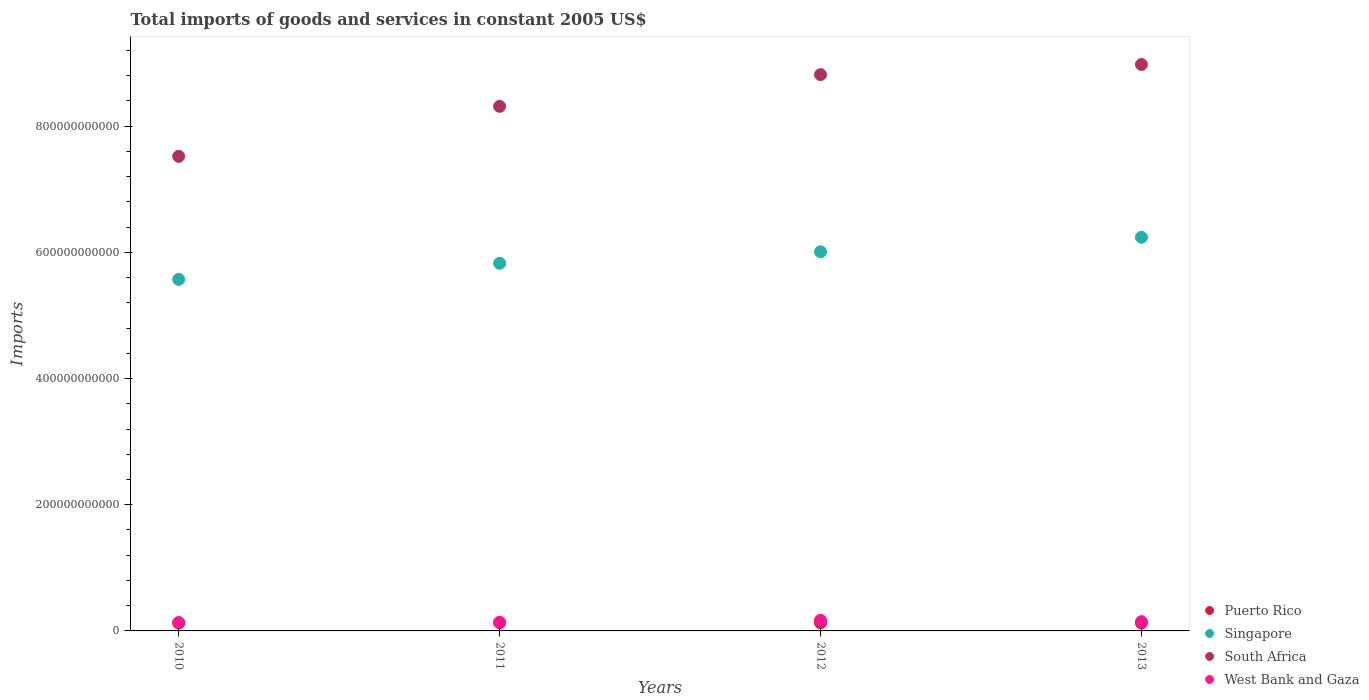Is the number of dotlines equal to the number of legend labels?
Give a very brief answer. Yes. What is the total imports of goods and services in Singapore in 2012?
Make the answer very short. 6.01e+11. Across all years, what is the maximum total imports of goods and services in South Africa?
Provide a succinct answer. 8.98e+11. Across all years, what is the minimum total imports of goods and services in West Bank and Gaza?
Your response must be concise. 1.33e+1. In which year was the total imports of goods and services in West Bank and Gaza minimum?
Provide a succinct answer. 2010. What is the total total imports of goods and services in West Bank and Gaza in the graph?
Your answer should be compact. 5.85e+1. What is the difference between the total imports of goods and services in West Bank and Gaza in 2012 and that in 2013?
Give a very brief answer. 2.19e+09. What is the difference between the total imports of goods and services in West Bank and Gaza in 2013 and the total imports of goods and services in Singapore in 2012?
Make the answer very short. -5.86e+11. What is the average total imports of goods and services in South Africa per year?
Keep it short and to the point. 8.41e+11. In the year 2013, what is the difference between the total imports of goods and services in West Bank and Gaza and total imports of goods and services in Singapore?
Provide a short and direct response. -6.09e+11. What is the ratio of the total imports of goods and services in South Africa in 2011 to that in 2012?
Make the answer very short. 0.94. Is the difference between the total imports of goods and services in West Bank and Gaza in 2010 and 2011 greater than the difference between the total imports of goods and services in Singapore in 2010 and 2011?
Your answer should be very brief. Yes. What is the difference between the highest and the second highest total imports of goods and services in Puerto Rico?
Give a very brief answer. 2.42e+07. What is the difference between the highest and the lowest total imports of goods and services in Puerto Rico?
Provide a succinct answer. 4.58e+08. Is the sum of the total imports of goods and services in South Africa in 2010 and 2011 greater than the maximum total imports of goods and services in Singapore across all years?
Give a very brief answer. Yes. Is it the case that in every year, the sum of the total imports of goods and services in Singapore and total imports of goods and services in West Bank and Gaza  is greater than the sum of total imports of goods and services in South Africa and total imports of goods and services in Puerto Rico?
Offer a very short reply. No. Is the total imports of goods and services in Puerto Rico strictly greater than the total imports of goods and services in South Africa over the years?
Make the answer very short. No. Is the total imports of goods and services in West Bank and Gaza strictly less than the total imports of goods and services in Singapore over the years?
Give a very brief answer. Yes. What is the difference between two consecutive major ticks on the Y-axis?
Your response must be concise. 2.00e+11. Does the graph contain grids?
Give a very brief answer. No. How are the legend labels stacked?
Keep it short and to the point. Vertical. What is the title of the graph?
Keep it short and to the point. Total imports of goods and services in constant 2005 US$. What is the label or title of the X-axis?
Your response must be concise. Years. What is the label or title of the Y-axis?
Give a very brief answer. Imports. What is the Imports of Puerto Rico in 2010?
Keep it short and to the point. 1.25e+1. What is the Imports in Singapore in 2010?
Provide a short and direct response. 5.57e+11. What is the Imports of South Africa in 2010?
Offer a very short reply. 7.52e+11. What is the Imports in West Bank and Gaza in 2010?
Ensure brevity in your answer.  1.33e+1. What is the Imports of Puerto Rico in 2011?
Offer a terse response. 1.29e+1. What is the Imports of Singapore in 2011?
Make the answer very short. 5.83e+11. What is the Imports in South Africa in 2011?
Your answer should be very brief. 8.31e+11. What is the Imports of West Bank and Gaza in 2011?
Offer a terse response. 1.37e+1. What is the Imports in Puerto Rico in 2012?
Ensure brevity in your answer.  1.29e+1. What is the Imports of Singapore in 2012?
Offer a very short reply. 6.01e+11. What is the Imports of South Africa in 2012?
Keep it short and to the point. 8.82e+11. What is the Imports of West Bank and Gaza in 2012?
Your response must be concise. 1.68e+1. What is the Imports in Puerto Rico in 2013?
Provide a short and direct response. 1.27e+1. What is the Imports in Singapore in 2013?
Make the answer very short. 6.24e+11. What is the Imports in South Africa in 2013?
Your response must be concise. 8.98e+11. What is the Imports in West Bank and Gaza in 2013?
Offer a terse response. 1.47e+1. Across all years, what is the maximum Imports of Puerto Rico?
Your response must be concise. 1.29e+1. Across all years, what is the maximum Imports of Singapore?
Make the answer very short. 6.24e+11. Across all years, what is the maximum Imports of South Africa?
Provide a succinct answer. 8.98e+11. Across all years, what is the maximum Imports of West Bank and Gaza?
Give a very brief answer. 1.68e+1. Across all years, what is the minimum Imports in Puerto Rico?
Provide a short and direct response. 1.25e+1. Across all years, what is the minimum Imports of Singapore?
Provide a succinct answer. 5.57e+11. Across all years, what is the minimum Imports of South Africa?
Your answer should be very brief. 7.52e+11. Across all years, what is the minimum Imports of West Bank and Gaza?
Your answer should be compact. 1.33e+1. What is the total Imports of Puerto Rico in the graph?
Provide a short and direct response. 5.11e+1. What is the total Imports in Singapore in the graph?
Offer a very short reply. 2.36e+12. What is the total Imports in South Africa in the graph?
Your answer should be very brief. 3.36e+12. What is the total Imports in West Bank and Gaza in the graph?
Your answer should be compact. 5.85e+1. What is the difference between the Imports of Puerto Rico in 2010 and that in 2011?
Offer a terse response. -4.34e+08. What is the difference between the Imports of Singapore in 2010 and that in 2011?
Provide a succinct answer. -2.56e+1. What is the difference between the Imports in South Africa in 2010 and that in 2011?
Keep it short and to the point. -7.92e+1. What is the difference between the Imports in West Bank and Gaza in 2010 and that in 2011?
Your answer should be very brief. -4.48e+08. What is the difference between the Imports in Puerto Rico in 2010 and that in 2012?
Give a very brief answer. -4.58e+08. What is the difference between the Imports of Singapore in 2010 and that in 2012?
Give a very brief answer. -4.38e+1. What is the difference between the Imports in South Africa in 2010 and that in 2012?
Give a very brief answer. -1.30e+11. What is the difference between the Imports of West Bank and Gaza in 2010 and that in 2012?
Keep it short and to the point. -3.59e+09. What is the difference between the Imports in Puerto Rico in 2010 and that in 2013?
Make the answer very short. -2.29e+08. What is the difference between the Imports in Singapore in 2010 and that in 2013?
Ensure brevity in your answer.  -6.68e+1. What is the difference between the Imports of South Africa in 2010 and that in 2013?
Ensure brevity in your answer.  -1.46e+11. What is the difference between the Imports of West Bank and Gaza in 2010 and that in 2013?
Your answer should be very brief. -1.40e+09. What is the difference between the Imports in Puerto Rico in 2011 and that in 2012?
Your answer should be very brief. -2.42e+07. What is the difference between the Imports in Singapore in 2011 and that in 2012?
Provide a short and direct response. -1.82e+1. What is the difference between the Imports of South Africa in 2011 and that in 2012?
Provide a short and direct response. -5.03e+1. What is the difference between the Imports in West Bank and Gaza in 2011 and that in 2012?
Provide a succinct answer. -3.14e+09. What is the difference between the Imports of Puerto Rico in 2011 and that in 2013?
Provide a succinct answer. 2.05e+08. What is the difference between the Imports of Singapore in 2011 and that in 2013?
Offer a very short reply. -4.12e+1. What is the difference between the Imports in South Africa in 2011 and that in 2013?
Provide a short and direct response. -6.63e+1. What is the difference between the Imports in West Bank and Gaza in 2011 and that in 2013?
Your answer should be compact. -9.47e+08. What is the difference between the Imports in Puerto Rico in 2012 and that in 2013?
Ensure brevity in your answer.  2.29e+08. What is the difference between the Imports in Singapore in 2012 and that in 2013?
Your answer should be very brief. -2.30e+1. What is the difference between the Imports of South Africa in 2012 and that in 2013?
Offer a terse response. -1.60e+1. What is the difference between the Imports in West Bank and Gaza in 2012 and that in 2013?
Give a very brief answer. 2.19e+09. What is the difference between the Imports in Puerto Rico in 2010 and the Imports in Singapore in 2011?
Offer a very short reply. -5.70e+11. What is the difference between the Imports in Puerto Rico in 2010 and the Imports in South Africa in 2011?
Ensure brevity in your answer.  -8.19e+11. What is the difference between the Imports in Puerto Rico in 2010 and the Imports in West Bank and Gaza in 2011?
Your answer should be very brief. -1.22e+09. What is the difference between the Imports of Singapore in 2010 and the Imports of South Africa in 2011?
Offer a very short reply. -2.74e+11. What is the difference between the Imports of Singapore in 2010 and the Imports of West Bank and Gaza in 2011?
Your response must be concise. 5.43e+11. What is the difference between the Imports in South Africa in 2010 and the Imports in West Bank and Gaza in 2011?
Ensure brevity in your answer.  7.39e+11. What is the difference between the Imports of Puerto Rico in 2010 and the Imports of Singapore in 2012?
Make the answer very short. -5.88e+11. What is the difference between the Imports in Puerto Rico in 2010 and the Imports in South Africa in 2012?
Give a very brief answer. -8.69e+11. What is the difference between the Imports in Puerto Rico in 2010 and the Imports in West Bank and Gaza in 2012?
Offer a very short reply. -4.36e+09. What is the difference between the Imports of Singapore in 2010 and the Imports of South Africa in 2012?
Ensure brevity in your answer.  -3.25e+11. What is the difference between the Imports of Singapore in 2010 and the Imports of West Bank and Gaza in 2012?
Give a very brief answer. 5.40e+11. What is the difference between the Imports in South Africa in 2010 and the Imports in West Bank and Gaza in 2012?
Your answer should be very brief. 7.35e+11. What is the difference between the Imports in Puerto Rico in 2010 and the Imports in Singapore in 2013?
Offer a very short reply. -6.11e+11. What is the difference between the Imports in Puerto Rico in 2010 and the Imports in South Africa in 2013?
Keep it short and to the point. -8.85e+11. What is the difference between the Imports of Puerto Rico in 2010 and the Imports of West Bank and Gaza in 2013?
Make the answer very short. -2.17e+09. What is the difference between the Imports in Singapore in 2010 and the Imports in South Africa in 2013?
Make the answer very short. -3.41e+11. What is the difference between the Imports in Singapore in 2010 and the Imports in West Bank and Gaza in 2013?
Offer a very short reply. 5.43e+11. What is the difference between the Imports in South Africa in 2010 and the Imports in West Bank and Gaza in 2013?
Provide a short and direct response. 7.38e+11. What is the difference between the Imports in Puerto Rico in 2011 and the Imports in Singapore in 2012?
Your answer should be compact. -5.88e+11. What is the difference between the Imports of Puerto Rico in 2011 and the Imports of South Africa in 2012?
Your answer should be very brief. -8.69e+11. What is the difference between the Imports in Puerto Rico in 2011 and the Imports in West Bank and Gaza in 2012?
Your answer should be compact. -3.93e+09. What is the difference between the Imports of Singapore in 2011 and the Imports of South Africa in 2012?
Your answer should be compact. -2.99e+11. What is the difference between the Imports of Singapore in 2011 and the Imports of West Bank and Gaza in 2012?
Give a very brief answer. 5.66e+11. What is the difference between the Imports in South Africa in 2011 and the Imports in West Bank and Gaza in 2012?
Provide a short and direct response. 8.15e+11. What is the difference between the Imports of Puerto Rico in 2011 and the Imports of Singapore in 2013?
Offer a terse response. -6.11e+11. What is the difference between the Imports of Puerto Rico in 2011 and the Imports of South Africa in 2013?
Give a very brief answer. -8.85e+11. What is the difference between the Imports in Puerto Rico in 2011 and the Imports in West Bank and Gaza in 2013?
Provide a succinct answer. -1.74e+09. What is the difference between the Imports in Singapore in 2011 and the Imports in South Africa in 2013?
Offer a very short reply. -3.15e+11. What is the difference between the Imports of Singapore in 2011 and the Imports of West Bank and Gaza in 2013?
Give a very brief answer. 5.68e+11. What is the difference between the Imports of South Africa in 2011 and the Imports of West Bank and Gaza in 2013?
Your answer should be compact. 8.17e+11. What is the difference between the Imports of Puerto Rico in 2012 and the Imports of Singapore in 2013?
Your response must be concise. -6.11e+11. What is the difference between the Imports of Puerto Rico in 2012 and the Imports of South Africa in 2013?
Provide a succinct answer. -8.85e+11. What is the difference between the Imports in Puerto Rico in 2012 and the Imports in West Bank and Gaza in 2013?
Ensure brevity in your answer.  -1.71e+09. What is the difference between the Imports in Singapore in 2012 and the Imports in South Africa in 2013?
Your response must be concise. -2.97e+11. What is the difference between the Imports of Singapore in 2012 and the Imports of West Bank and Gaza in 2013?
Make the answer very short. 5.86e+11. What is the difference between the Imports of South Africa in 2012 and the Imports of West Bank and Gaza in 2013?
Make the answer very short. 8.67e+11. What is the average Imports in Puerto Rico per year?
Give a very brief answer. 1.28e+1. What is the average Imports of Singapore per year?
Ensure brevity in your answer.  5.91e+11. What is the average Imports in South Africa per year?
Ensure brevity in your answer.  8.41e+11. What is the average Imports in West Bank and Gaza per year?
Offer a very short reply. 1.46e+1. In the year 2010, what is the difference between the Imports of Puerto Rico and Imports of Singapore?
Give a very brief answer. -5.45e+11. In the year 2010, what is the difference between the Imports in Puerto Rico and Imports in South Africa?
Your response must be concise. -7.40e+11. In the year 2010, what is the difference between the Imports in Puerto Rico and Imports in West Bank and Gaza?
Keep it short and to the point. -7.76e+08. In the year 2010, what is the difference between the Imports of Singapore and Imports of South Africa?
Your answer should be very brief. -1.95e+11. In the year 2010, what is the difference between the Imports in Singapore and Imports in West Bank and Gaza?
Make the answer very short. 5.44e+11. In the year 2010, what is the difference between the Imports in South Africa and Imports in West Bank and Gaza?
Your answer should be very brief. 7.39e+11. In the year 2011, what is the difference between the Imports of Puerto Rico and Imports of Singapore?
Your response must be concise. -5.70e+11. In the year 2011, what is the difference between the Imports of Puerto Rico and Imports of South Africa?
Your response must be concise. -8.19e+11. In the year 2011, what is the difference between the Imports of Puerto Rico and Imports of West Bank and Gaza?
Make the answer very short. -7.90e+08. In the year 2011, what is the difference between the Imports of Singapore and Imports of South Africa?
Your answer should be very brief. -2.49e+11. In the year 2011, what is the difference between the Imports of Singapore and Imports of West Bank and Gaza?
Ensure brevity in your answer.  5.69e+11. In the year 2011, what is the difference between the Imports in South Africa and Imports in West Bank and Gaza?
Offer a terse response. 8.18e+11. In the year 2012, what is the difference between the Imports of Puerto Rico and Imports of Singapore?
Your answer should be compact. -5.88e+11. In the year 2012, what is the difference between the Imports of Puerto Rico and Imports of South Africa?
Give a very brief answer. -8.69e+11. In the year 2012, what is the difference between the Imports of Puerto Rico and Imports of West Bank and Gaza?
Provide a succinct answer. -3.90e+09. In the year 2012, what is the difference between the Imports of Singapore and Imports of South Africa?
Keep it short and to the point. -2.81e+11. In the year 2012, what is the difference between the Imports in Singapore and Imports in West Bank and Gaza?
Keep it short and to the point. 5.84e+11. In the year 2012, what is the difference between the Imports of South Africa and Imports of West Bank and Gaza?
Offer a very short reply. 8.65e+11. In the year 2013, what is the difference between the Imports in Puerto Rico and Imports in Singapore?
Keep it short and to the point. -6.11e+11. In the year 2013, what is the difference between the Imports of Puerto Rico and Imports of South Africa?
Provide a succinct answer. -8.85e+11. In the year 2013, what is the difference between the Imports of Puerto Rico and Imports of West Bank and Gaza?
Ensure brevity in your answer.  -1.94e+09. In the year 2013, what is the difference between the Imports of Singapore and Imports of South Africa?
Your answer should be very brief. -2.74e+11. In the year 2013, what is the difference between the Imports of Singapore and Imports of West Bank and Gaza?
Offer a very short reply. 6.09e+11. In the year 2013, what is the difference between the Imports of South Africa and Imports of West Bank and Gaza?
Offer a terse response. 8.83e+11. What is the ratio of the Imports in Puerto Rico in 2010 to that in 2011?
Provide a succinct answer. 0.97. What is the ratio of the Imports of Singapore in 2010 to that in 2011?
Give a very brief answer. 0.96. What is the ratio of the Imports of South Africa in 2010 to that in 2011?
Your answer should be compact. 0.9. What is the ratio of the Imports in West Bank and Gaza in 2010 to that in 2011?
Your answer should be compact. 0.97. What is the ratio of the Imports in Puerto Rico in 2010 to that in 2012?
Make the answer very short. 0.96. What is the ratio of the Imports in Singapore in 2010 to that in 2012?
Give a very brief answer. 0.93. What is the ratio of the Imports in South Africa in 2010 to that in 2012?
Offer a terse response. 0.85. What is the ratio of the Imports in West Bank and Gaza in 2010 to that in 2012?
Make the answer very short. 0.79. What is the ratio of the Imports in Puerto Rico in 2010 to that in 2013?
Provide a succinct answer. 0.98. What is the ratio of the Imports of Singapore in 2010 to that in 2013?
Ensure brevity in your answer.  0.89. What is the ratio of the Imports of South Africa in 2010 to that in 2013?
Offer a terse response. 0.84. What is the ratio of the Imports of West Bank and Gaza in 2010 to that in 2013?
Provide a succinct answer. 0.9. What is the ratio of the Imports in Singapore in 2011 to that in 2012?
Your response must be concise. 0.97. What is the ratio of the Imports of South Africa in 2011 to that in 2012?
Ensure brevity in your answer.  0.94. What is the ratio of the Imports of West Bank and Gaza in 2011 to that in 2012?
Offer a very short reply. 0.81. What is the ratio of the Imports in Puerto Rico in 2011 to that in 2013?
Your answer should be very brief. 1.02. What is the ratio of the Imports in Singapore in 2011 to that in 2013?
Your response must be concise. 0.93. What is the ratio of the Imports of South Africa in 2011 to that in 2013?
Make the answer very short. 0.93. What is the ratio of the Imports in West Bank and Gaza in 2011 to that in 2013?
Ensure brevity in your answer.  0.94. What is the ratio of the Imports of Singapore in 2012 to that in 2013?
Your answer should be compact. 0.96. What is the ratio of the Imports of South Africa in 2012 to that in 2013?
Keep it short and to the point. 0.98. What is the ratio of the Imports in West Bank and Gaza in 2012 to that in 2013?
Offer a terse response. 1.15. What is the difference between the highest and the second highest Imports in Puerto Rico?
Offer a very short reply. 2.42e+07. What is the difference between the highest and the second highest Imports of Singapore?
Your answer should be compact. 2.30e+1. What is the difference between the highest and the second highest Imports of South Africa?
Provide a succinct answer. 1.60e+1. What is the difference between the highest and the second highest Imports of West Bank and Gaza?
Keep it short and to the point. 2.19e+09. What is the difference between the highest and the lowest Imports of Puerto Rico?
Ensure brevity in your answer.  4.58e+08. What is the difference between the highest and the lowest Imports of Singapore?
Offer a terse response. 6.68e+1. What is the difference between the highest and the lowest Imports of South Africa?
Make the answer very short. 1.46e+11. What is the difference between the highest and the lowest Imports of West Bank and Gaza?
Offer a terse response. 3.59e+09. 